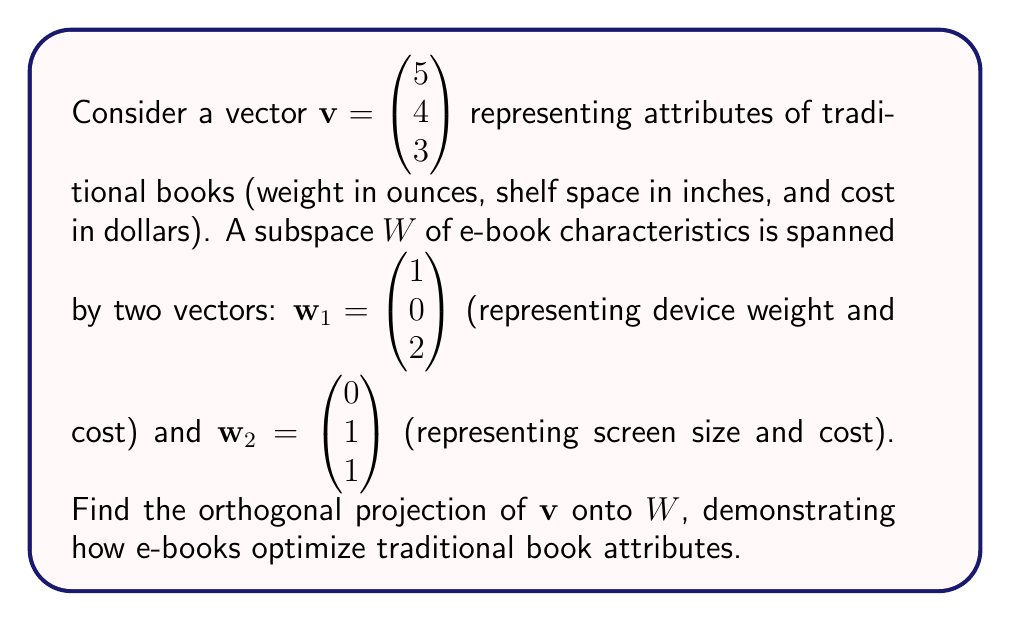Solve this math problem. To find the orthogonal projection of $\mathbf{v}$ onto $W$, we'll follow these steps:

1) First, we need to find an orthonormal basis for $W$. We'll use the Gram-Schmidt process on $\mathbf{w}_1$ and $\mathbf{w}_2$.

   $\mathbf{u}_1 = \mathbf{w}_1 = \begin{pmatrix} 1 \\ 0 \\ 2 \end{pmatrix}$
   
   $\mathbf{u}_2 = \mathbf{w}_2 - \text{proj}_{\mathbf{u}_1}\mathbf{w}_2 = \begin{pmatrix} 0 \\ 1 \\ 1 \end{pmatrix} - \frac{\mathbf{w}_2 \cdot \mathbf{u}_1}{\|\mathbf{u}_1\|^2}\mathbf{u}_1$

   $= \begin{pmatrix} 0 \\ 1 \\ 1 \end{pmatrix} - \frac{2}{5}\begin{pmatrix} 1 \\ 0 \\ 2 \end{pmatrix} = \begin{pmatrix} -0.4 \\ 1 \\ 0.2 \end{pmatrix}$

2) Now we normalize these vectors:

   $\mathbf{e}_1 = \frac{\mathbf{u}_1}{\|\mathbf{u}_1\|} = \frac{1}{\sqrt{5}}\begin{pmatrix} 1 \\ 0 \\ 2 \end{pmatrix}$
   
   $\mathbf{e}_2 = \frac{\mathbf{u}_2}{\|\mathbf{u}_2\|} = \frac{1}{\sqrt{1.2}}\begin{pmatrix} -0.4 \\ 1 \\ 0.2 \end{pmatrix}$

3) The orthogonal projection of $\mathbf{v}$ onto $W$ is given by:

   $\text{proj}_W\mathbf{v} = (\mathbf{v} \cdot \mathbf{e}_1)\mathbf{e}_1 + (\mathbf{v} \cdot \mathbf{e}_2)\mathbf{e}_2$

4) Let's calculate the dot products:

   $\mathbf{v} \cdot \mathbf{e}_1 = \frac{1}{\sqrt{5}}(5 + 6) = \frac{11}{\sqrt{5}}$
   
   $\mathbf{v} \cdot \mathbf{e}_2 = \frac{1}{\sqrt{1.2}}(-2 + 4 + 0.6) = \frac{2.6}{\sqrt{1.2}}$

5) Now we can calculate the projection:

   $\text{proj}_W\mathbf{v} = \frac{11}{\sqrt{5}} \cdot \frac{1}{\sqrt{5}}\begin{pmatrix} 1 \\ 0 \\ 2 \end{pmatrix} + \frac{2.6}{\sqrt{1.2}} \cdot \frac{1}{\sqrt{1.2}}\begin{pmatrix} -0.4 \\ 1 \\ 0.2 \end{pmatrix}$

   $= \frac{11}{5}\begin{pmatrix} 1 \\ 0 \\ 2 \end{pmatrix} + \frac{2.6}{1.2}\begin{pmatrix} -0.4 \\ 1 \\ 0.2 \end{pmatrix}$

   $= \begin{pmatrix} 2.2 \\ 0 \\ 4.4 \end{pmatrix} + \begin{pmatrix} -0.867 \\ 2.167 \\ 0.433 \end{pmatrix}$

   $= \begin{pmatrix} 1.333 \\ 2.167 \\ 4.833 \end{pmatrix}$

This projection represents how e-book characteristics optimize traditional book attributes, reducing physical weight while maintaining content accessibility and adjusting costs.
Answer: The orthogonal projection of $\mathbf{v}$ onto $W$ is:

$$\text{proj}_W\mathbf{v} = \begin{pmatrix} 1.333 \\ 2.167 \\ 4.833 \end{pmatrix}$$ 